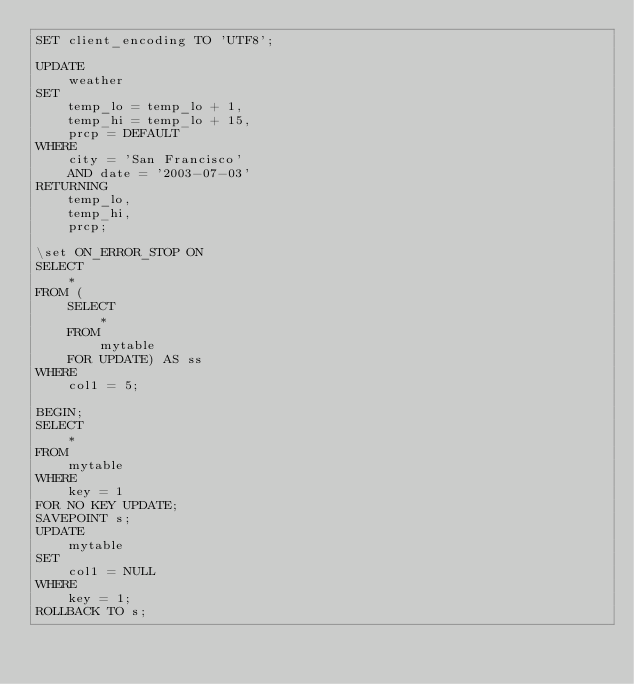<code> <loc_0><loc_0><loc_500><loc_500><_SQL_>SET client_encoding TO 'UTF8';

UPDATE
    weather
SET
    temp_lo = temp_lo + 1,
    temp_hi = temp_lo + 15,
    prcp = DEFAULT
WHERE
    city = 'San Francisco'
    AND date = '2003-07-03'
RETURNING
    temp_lo,
    temp_hi,
    prcp;

\set ON_ERROR_STOP ON
SELECT
    *
FROM (
    SELECT
        *
    FROM
        mytable
    FOR UPDATE) AS ss
WHERE
    col1 = 5;

BEGIN;
SELECT
    *
FROM
    mytable
WHERE
    key = 1
FOR NO KEY UPDATE;
SAVEPOINT s;
UPDATE
    mytable
SET
    col1 = NULL
WHERE
    key = 1;
ROLLBACK TO s;

</code> 